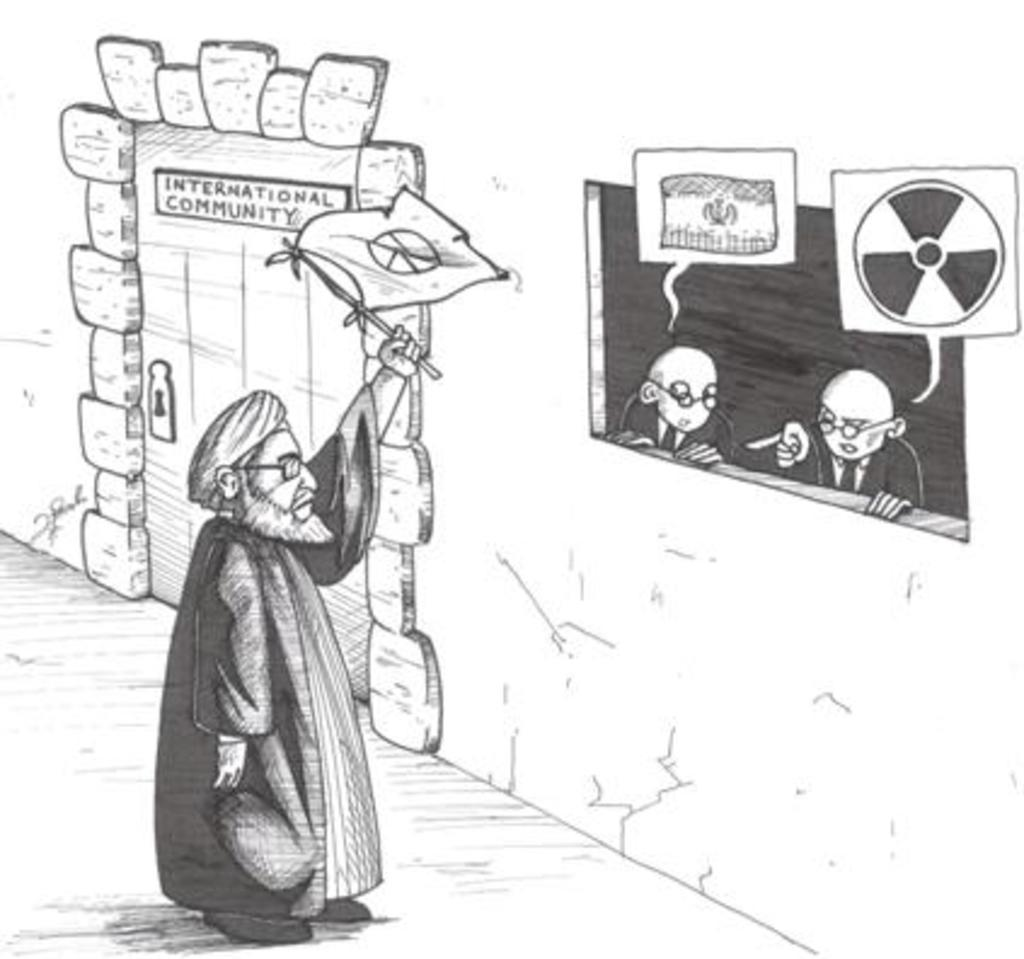What is featured in the image? There is a poster in the image. What type of content is on the poster? The poster contains diagrams. What type of plants can be seen in the garden depicted on the poster? There is no garden depicted on the poster; it contains diagrams. What is the current state of the zinc in the image? There is no zinc present in the image; it only features a poster with diagrams. 